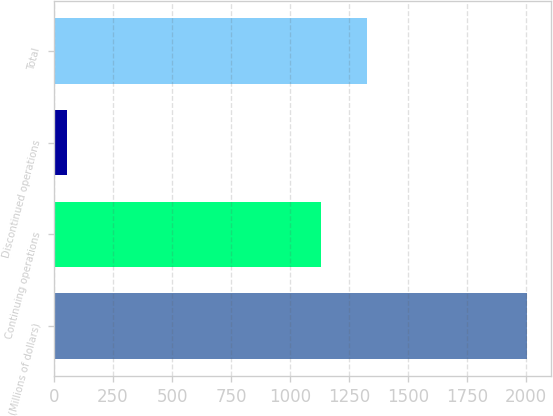Convert chart. <chart><loc_0><loc_0><loc_500><loc_500><bar_chart><fcel>(Millions of dollars)<fcel>Continuing operations<fcel>Discontinued operations<fcel>Total<nl><fcel>2005<fcel>1131<fcel>53<fcel>1326.2<nl></chart> 